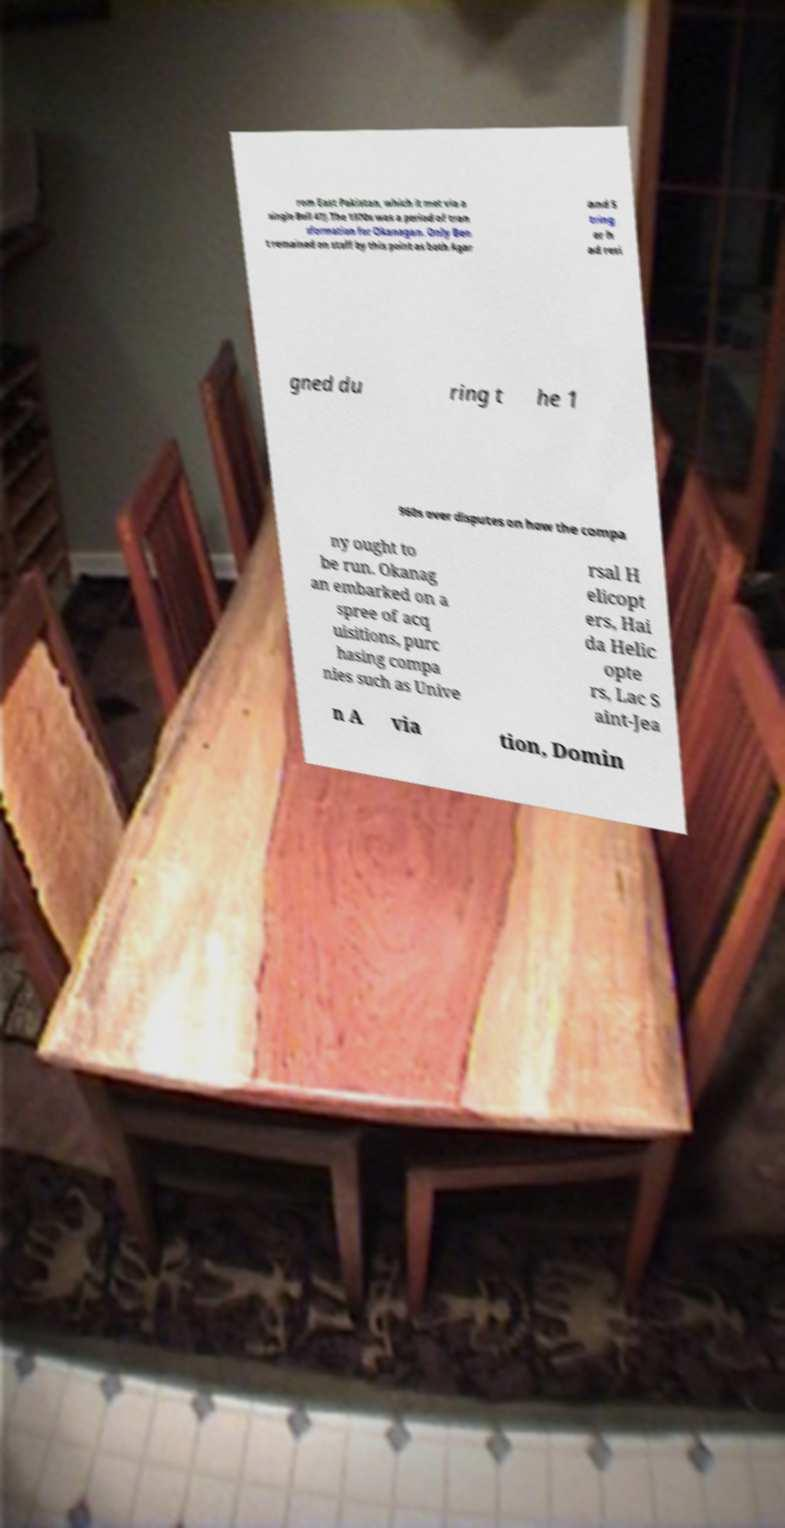Can you accurately transcribe the text from the provided image for me? rom East Pakistan, which it met via a single Bell 47J.The 1970s was a period of tran sformation for Okanagan. Only Ben t remained on staff by this point as both Agar and S tring er h ad resi gned du ring t he 1 960s over disputes on how the compa ny ought to be run. Okanag an embarked on a spree of acq uisitions, purc hasing compa nies such as Unive rsal H elicopt ers, Hai da Helic opte rs, Lac S aint-Jea n A via tion, Domin 